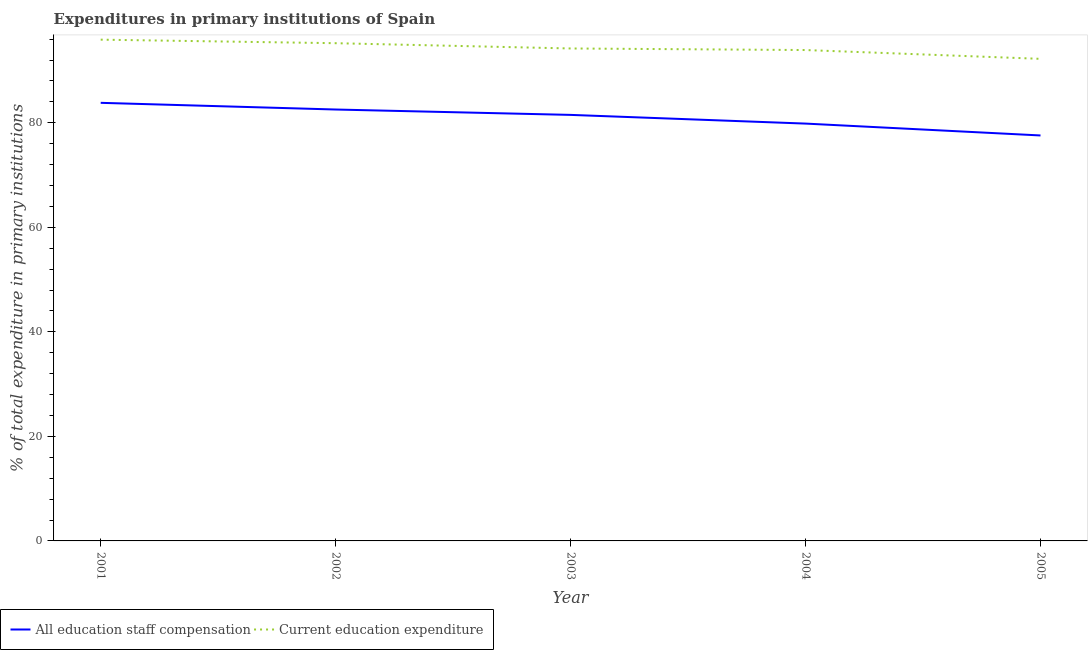What is the expenditure in education in 2002?
Provide a short and direct response. 95.23. Across all years, what is the maximum expenditure in education?
Your answer should be compact. 95.9. Across all years, what is the minimum expenditure in education?
Provide a short and direct response. 92.23. In which year was the expenditure in education maximum?
Your answer should be very brief. 2001. In which year was the expenditure in education minimum?
Provide a succinct answer. 2005. What is the total expenditure in staff compensation in the graph?
Make the answer very short. 405.29. What is the difference between the expenditure in staff compensation in 2003 and that in 2005?
Your response must be concise. 3.93. What is the difference between the expenditure in education in 2004 and the expenditure in staff compensation in 2001?
Ensure brevity in your answer.  10.1. What is the average expenditure in staff compensation per year?
Provide a short and direct response. 81.06. In the year 2001, what is the difference between the expenditure in education and expenditure in staff compensation?
Ensure brevity in your answer.  12.09. What is the ratio of the expenditure in staff compensation in 2001 to that in 2004?
Provide a succinct answer. 1.05. Is the expenditure in staff compensation in 2001 less than that in 2002?
Ensure brevity in your answer.  No. Is the difference between the expenditure in education in 2002 and 2005 greater than the difference between the expenditure in staff compensation in 2002 and 2005?
Provide a short and direct response. No. What is the difference between the highest and the second highest expenditure in education?
Your response must be concise. 0.68. What is the difference between the highest and the lowest expenditure in staff compensation?
Keep it short and to the point. 6.24. In how many years, is the expenditure in staff compensation greater than the average expenditure in staff compensation taken over all years?
Offer a very short reply. 3. Is the sum of the expenditure in education in 2001 and 2004 greater than the maximum expenditure in staff compensation across all years?
Your response must be concise. Yes. Is the expenditure in staff compensation strictly greater than the expenditure in education over the years?
Your answer should be compact. No. How many years are there in the graph?
Provide a short and direct response. 5. Are the values on the major ticks of Y-axis written in scientific E-notation?
Offer a very short reply. No. Does the graph contain any zero values?
Provide a short and direct response. No. How many legend labels are there?
Offer a terse response. 2. What is the title of the graph?
Provide a succinct answer. Expenditures in primary institutions of Spain. Does "Imports" appear as one of the legend labels in the graph?
Ensure brevity in your answer.  No. What is the label or title of the X-axis?
Ensure brevity in your answer.  Year. What is the label or title of the Y-axis?
Ensure brevity in your answer.  % of total expenditure in primary institutions. What is the % of total expenditure in primary institutions in All education staff compensation in 2001?
Give a very brief answer. 83.82. What is the % of total expenditure in primary institutions in Current education expenditure in 2001?
Give a very brief answer. 95.9. What is the % of total expenditure in primary institutions in All education staff compensation in 2002?
Offer a very short reply. 82.54. What is the % of total expenditure in primary institutions in Current education expenditure in 2002?
Your answer should be very brief. 95.23. What is the % of total expenditure in primary institutions of All education staff compensation in 2003?
Your answer should be compact. 81.51. What is the % of total expenditure in primary institutions of Current education expenditure in 2003?
Give a very brief answer. 94.22. What is the % of total expenditure in primary institutions of All education staff compensation in 2004?
Ensure brevity in your answer.  79.85. What is the % of total expenditure in primary institutions in Current education expenditure in 2004?
Offer a very short reply. 93.92. What is the % of total expenditure in primary institutions in All education staff compensation in 2005?
Offer a very short reply. 77.58. What is the % of total expenditure in primary institutions in Current education expenditure in 2005?
Offer a terse response. 92.23. Across all years, what is the maximum % of total expenditure in primary institutions of All education staff compensation?
Offer a very short reply. 83.82. Across all years, what is the maximum % of total expenditure in primary institutions in Current education expenditure?
Give a very brief answer. 95.9. Across all years, what is the minimum % of total expenditure in primary institutions in All education staff compensation?
Your answer should be very brief. 77.58. Across all years, what is the minimum % of total expenditure in primary institutions of Current education expenditure?
Offer a terse response. 92.23. What is the total % of total expenditure in primary institutions in All education staff compensation in the graph?
Make the answer very short. 405.29. What is the total % of total expenditure in primary institutions of Current education expenditure in the graph?
Offer a very short reply. 471.5. What is the difference between the % of total expenditure in primary institutions of All education staff compensation in 2001 and that in 2002?
Your response must be concise. 1.28. What is the difference between the % of total expenditure in primary institutions in Current education expenditure in 2001 and that in 2002?
Offer a terse response. 0.68. What is the difference between the % of total expenditure in primary institutions in All education staff compensation in 2001 and that in 2003?
Provide a succinct answer. 2.31. What is the difference between the % of total expenditure in primary institutions in Current education expenditure in 2001 and that in 2003?
Give a very brief answer. 1.68. What is the difference between the % of total expenditure in primary institutions in All education staff compensation in 2001 and that in 2004?
Your answer should be compact. 3.97. What is the difference between the % of total expenditure in primary institutions of Current education expenditure in 2001 and that in 2004?
Offer a terse response. 1.99. What is the difference between the % of total expenditure in primary institutions in All education staff compensation in 2001 and that in 2005?
Make the answer very short. 6.24. What is the difference between the % of total expenditure in primary institutions in Current education expenditure in 2001 and that in 2005?
Offer a terse response. 3.67. What is the difference between the % of total expenditure in primary institutions of All education staff compensation in 2002 and that in 2003?
Your response must be concise. 1.03. What is the difference between the % of total expenditure in primary institutions in Current education expenditure in 2002 and that in 2003?
Provide a short and direct response. 1.01. What is the difference between the % of total expenditure in primary institutions of All education staff compensation in 2002 and that in 2004?
Provide a short and direct response. 2.69. What is the difference between the % of total expenditure in primary institutions in Current education expenditure in 2002 and that in 2004?
Keep it short and to the point. 1.31. What is the difference between the % of total expenditure in primary institutions in All education staff compensation in 2002 and that in 2005?
Make the answer very short. 4.96. What is the difference between the % of total expenditure in primary institutions in Current education expenditure in 2002 and that in 2005?
Offer a terse response. 3. What is the difference between the % of total expenditure in primary institutions of All education staff compensation in 2003 and that in 2004?
Your answer should be compact. 1.66. What is the difference between the % of total expenditure in primary institutions in Current education expenditure in 2003 and that in 2004?
Provide a short and direct response. 0.3. What is the difference between the % of total expenditure in primary institutions in All education staff compensation in 2003 and that in 2005?
Provide a short and direct response. 3.93. What is the difference between the % of total expenditure in primary institutions of Current education expenditure in 2003 and that in 2005?
Make the answer very short. 1.99. What is the difference between the % of total expenditure in primary institutions of All education staff compensation in 2004 and that in 2005?
Ensure brevity in your answer.  2.27. What is the difference between the % of total expenditure in primary institutions of Current education expenditure in 2004 and that in 2005?
Your answer should be very brief. 1.69. What is the difference between the % of total expenditure in primary institutions of All education staff compensation in 2001 and the % of total expenditure in primary institutions of Current education expenditure in 2002?
Offer a very short reply. -11.41. What is the difference between the % of total expenditure in primary institutions of All education staff compensation in 2001 and the % of total expenditure in primary institutions of Current education expenditure in 2003?
Your answer should be very brief. -10.4. What is the difference between the % of total expenditure in primary institutions of All education staff compensation in 2001 and the % of total expenditure in primary institutions of Current education expenditure in 2004?
Give a very brief answer. -10.1. What is the difference between the % of total expenditure in primary institutions in All education staff compensation in 2001 and the % of total expenditure in primary institutions in Current education expenditure in 2005?
Keep it short and to the point. -8.41. What is the difference between the % of total expenditure in primary institutions in All education staff compensation in 2002 and the % of total expenditure in primary institutions in Current education expenditure in 2003?
Your answer should be compact. -11.68. What is the difference between the % of total expenditure in primary institutions in All education staff compensation in 2002 and the % of total expenditure in primary institutions in Current education expenditure in 2004?
Your answer should be compact. -11.38. What is the difference between the % of total expenditure in primary institutions in All education staff compensation in 2002 and the % of total expenditure in primary institutions in Current education expenditure in 2005?
Provide a short and direct response. -9.69. What is the difference between the % of total expenditure in primary institutions in All education staff compensation in 2003 and the % of total expenditure in primary institutions in Current education expenditure in 2004?
Offer a very short reply. -12.41. What is the difference between the % of total expenditure in primary institutions in All education staff compensation in 2003 and the % of total expenditure in primary institutions in Current education expenditure in 2005?
Offer a very short reply. -10.72. What is the difference between the % of total expenditure in primary institutions in All education staff compensation in 2004 and the % of total expenditure in primary institutions in Current education expenditure in 2005?
Your response must be concise. -12.39. What is the average % of total expenditure in primary institutions of All education staff compensation per year?
Ensure brevity in your answer.  81.06. What is the average % of total expenditure in primary institutions of Current education expenditure per year?
Make the answer very short. 94.3. In the year 2001, what is the difference between the % of total expenditure in primary institutions in All education staff compensation and % of total expenditure in primary institutions in Current education expenditure?
Provide a short and direct response. -12.09. In the year 2002, what is the difference between the % of total expenditure in primary institutions in All education staff compensation and % of total expenditure in primary institutions in Current education expenditure?
Your response must be concise. -12.69. In the year 2003, what is the difference between the % of total expenditure in primary institutions in All education staff compensation and % of total expenditure in primary institutions in Current education expenditure?
Ensure brevity in your answer.  -12.71. In the year 2004, what is the difference between the % of total expenditure in primary institutions of All education staff compensation and % of total expenditure in primary institutions of Current education expenditure?
Make the answer very short. -14.07. In the year 2005, what is the difference between the % of total expenditure in primary institutions of All education staff compensation and % of total expenditure in primary institutions of Current education expenditure?
Your response must be concise. -14.66. What is the ratio of the % of total expenditure in primary institutions of All education staff compensation in 2001 to that in 2002?
Provide a succinct answer. 1.02. What is the ratio of the % of total expenditure in primary institutions of Current education expenditure in 2001 to that in 2002?
Your response must be concise. 1.01. What is the ratio of the % of total expenditure in primary institutions in All education staff compensation in 2001 to that in 2003?
Keep it short and to the point. 1.03. What is the ratio of the % of total expenditure in primary institutions in Current education expenditure in 2001 to that in 2003?
Make the answer very short. 1.02. What is the ratio of the % of total expenditure in primary institutions of All education staff compensation in 2001 to that in 2004?
Offer a very short reply. 1.05. What is the ratio of the % of total expenditure in primary institutions of Current education expenditure in 2001 to that in 2004?
Give a very brief answer. 1.02. What is the ratio of the % of total expenditure in primary institutions in All education staff compensation in 2001 to that in 2005?
Ensure brevity in your answer.  1.08. What is the ratio of the % of total expenditure in primary institutions of Current education expenditure in 2001 to that in 2005?
Ensure brevity in your answer.  1.04. What is the ratio of the % of total expenditure in primary institutions of All education staff compensation in 2002 to that in 2003?
Give a very brief answer. 1.01. What is the ratio of the % of total expenditure in primary institutions in Current education expenditure in 2002 to that in 2003?
Provide a succinct answer. 1.01. What is the ratio of the % of total expenditure in primary institutions of All education staff compensation in 2002 to that in 2004?
Provide a succinct answer. 1.03. What is the ratio of the % of total expenditure in primary institutions of Current education expenditure in 2002 to that in 2004?
Keep it short and to the point. 1.01. What is the ratio of the % of total expenditure in primary institutions in All education staff compensation in 2002 to that in 2005?
Give a very brief answer. 1.06. What is the ratio of the % of total expenditure in primary institutions in Current education expenditure in 2002 to that in 2005?
Make the answer very short. 1.03. What is the ratio of the % of total expenditure in primary institutions of All education staff compensation in 2003 to that in 2004?
Keep it short and to the point. 1.02. What is the ratio of the % of total expenditure in primary institutions in All education staff compensation in 2003 to that in 2005?
Give a very brief answer. 1.05. What is the ratio of the % of total expenditure in primary institutions in Current education expenditure in 2003 to that in 2005?
Provide a short and direct response. 1.02. What is the ratio of the % of total expenditure in primary institutions in All education staff compensation in 2004 to that in 2005?
Give a very brief answer. 1.03. What is the ratio of the % of total expenditure in primary institutions in Current education expenditure in 2004 to that in 2005?
Offer a terse response. 1.02. What is the difference between the highest and the second highest % of total expenditure in primary institutions in All education staff compensation?
Give a very brief answer. 1.28. What is the difference between the highest and the second highest % of total expenditure in primary institutions in Current education expenditure?
Keep it short and to the point. 0.68. What is the difference between the highest and the lowest % of total expenditure in primary institutions in All education staff compensation?
Your answer should be very brief. 6.24. What is the difference between the highest and the lowest % of total expenditure in primary institutions of Current education expenditure?
Keep it short and to the point. 3.67. 